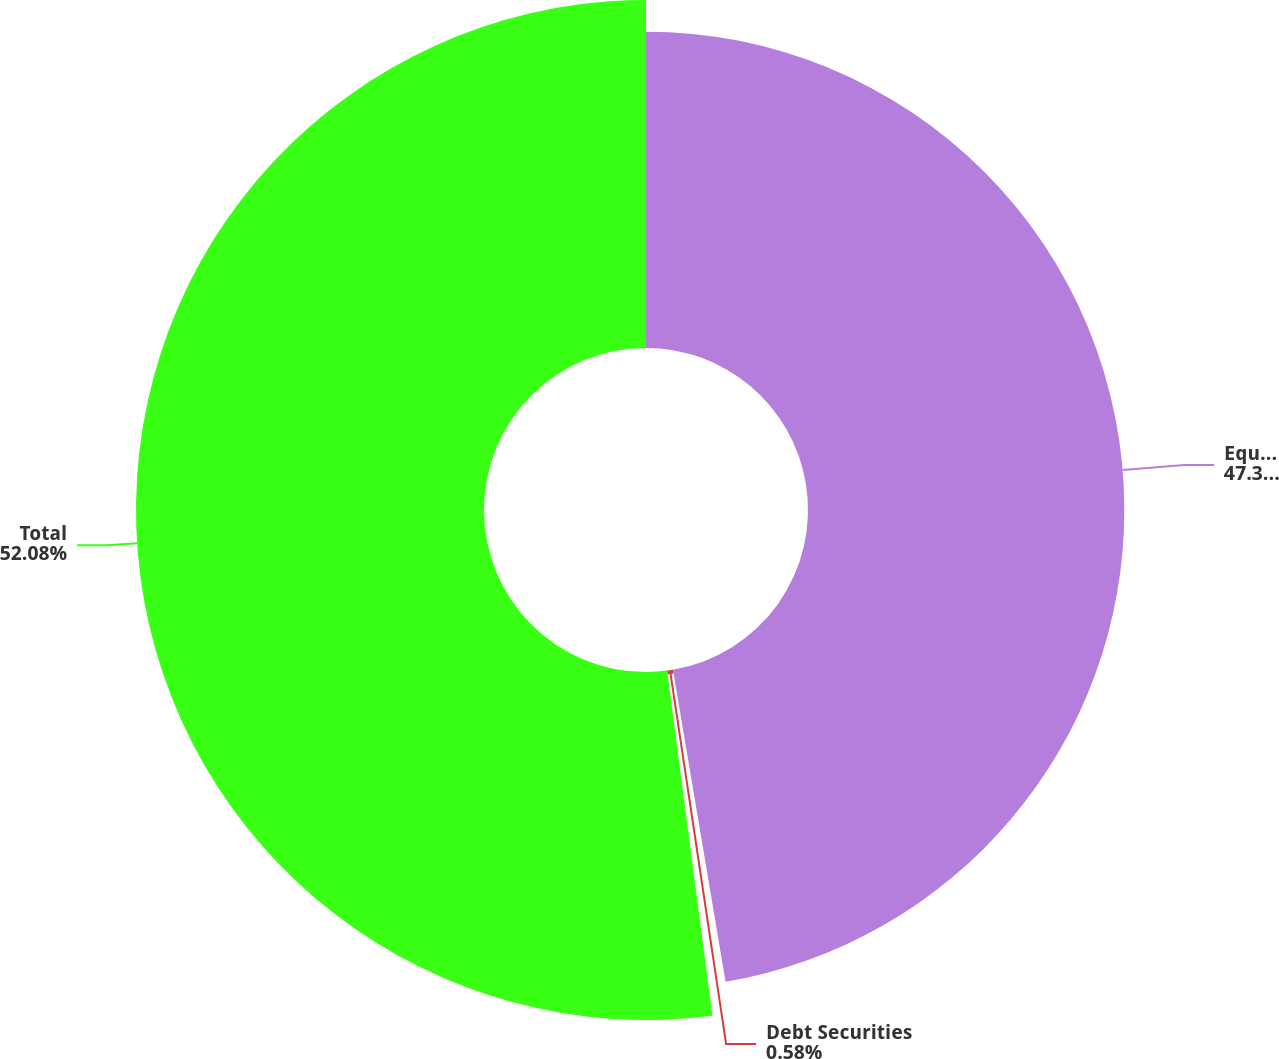<chart> <loc_0><loc_0><loc_500><loc_500><pie_chart><fcel>Equity Securities<fcel>Debt Securities<fcel>Total<nl><fcel>47.34%<fcel>0.58%<fcel>52.08%<nl></chart> 